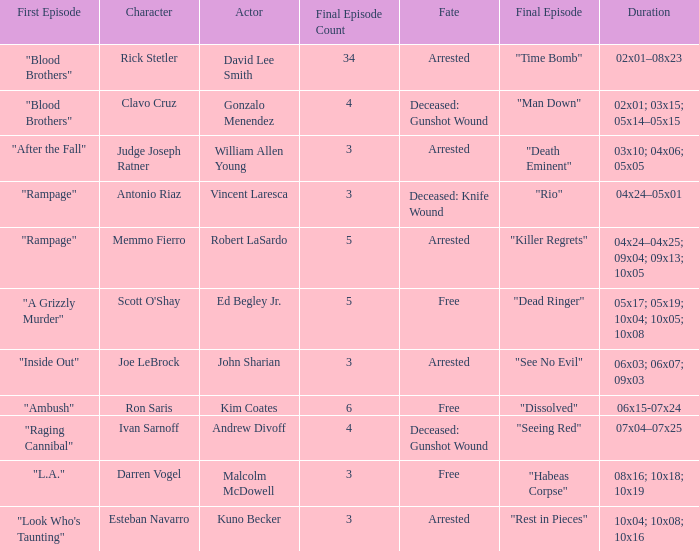What's the total number of final epbeingode count with character being rick stetler 1.0. 